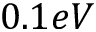Convert formula to latex. <formula><loc_0><loc_0><loc_500><loc_500>0 . 1 e V</formula> 